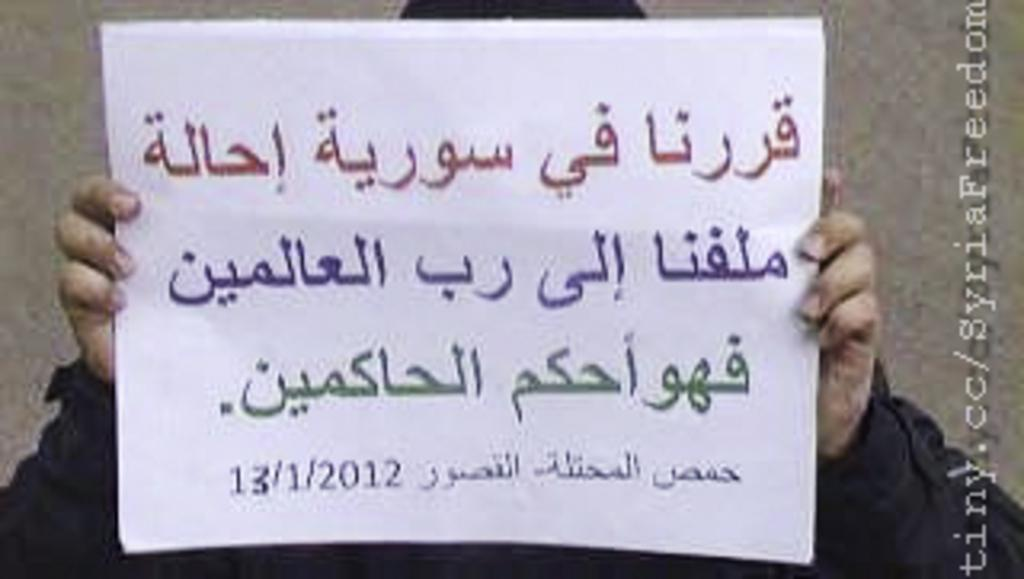<image>
Create a compact narrative representing the image presented. A man holding a sign in Arabic that is dated 13/1/2012. 